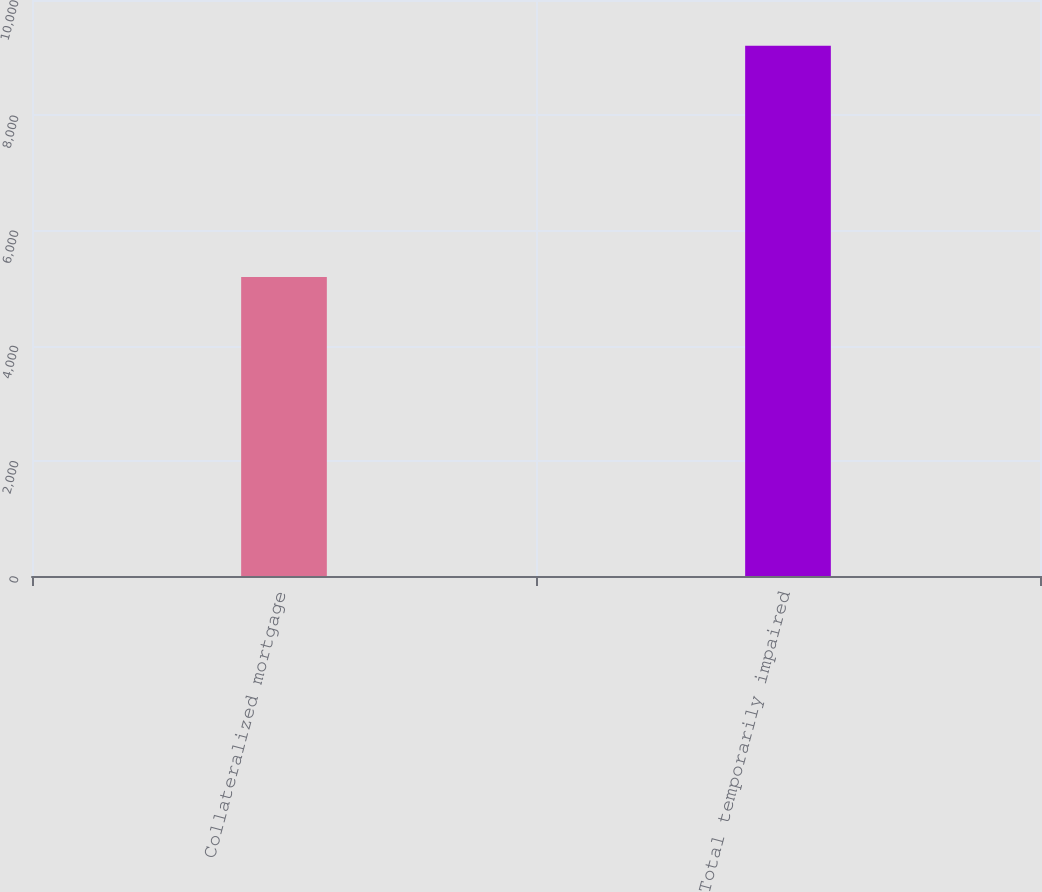Convert chart. <chart><loc_0><loc_0><loc_500><loc_500><bar_chart><fcel>Collateralized mortgage<fcel>Total temporarily impaired<nl><fcel>5190<fcel>9204<nl></chart> 